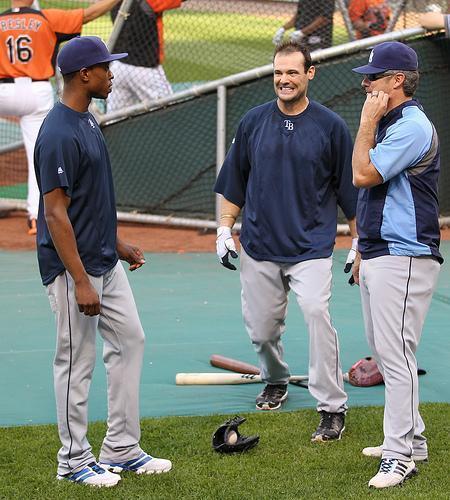How many players for the blue team are shown here?
Give a very brief answer. 3. How many bats are lying on the ground?
Give a very brief answer. 2. How many people are wearing hats?
Give a very brief answer. 2. How many men are wearing blue caps?
Give a very brief answer. 2. How many people wear black sneaker?
Give a very brief answer. 1. 